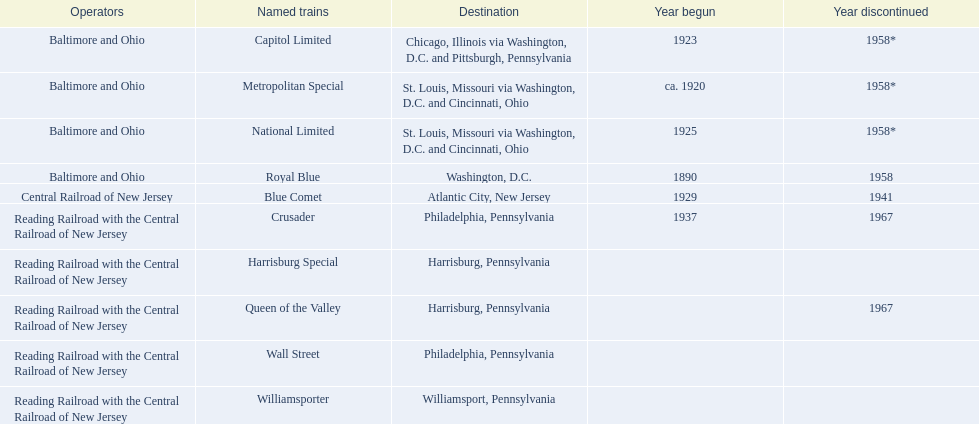What were all of the destinations? Chicago, Illinois via Washington, D.C. and Pittsburgh, Pennsylvania, St. Louis, Missouri via Washington, D.C. and Cincinnati, Ohio, St. Louis, Missouri via Washington, D.C. and Cincinnati, Ohio, Washington, D.C., Atlantic City, New Jersey, Philadelphia, Pennsylvania, Harrisburg, Pennsylvania, Harrisburg, Pennsylvania, Philadelphia, Pennsylvania, Williamsport, Pennsylvania. And what were the names of the trains? Capitol Limited, Metropolitan Special, National Limited, Royal Blue, Blue Comet, Crusader, Harrisburg Special, Queen of the Valley, Wall Street, Williamsporter. Of those, and along with wall street, which train ran to philadelphia, pennsylvania? Crusader. 